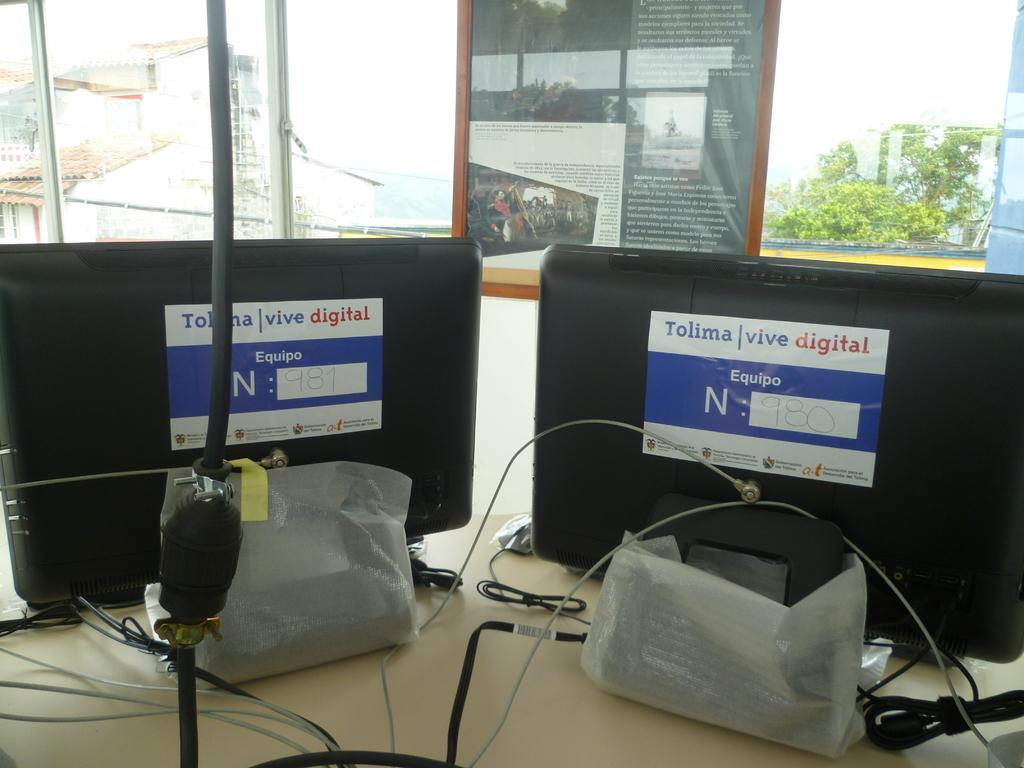How many systems can be seen in the image? There are two systems in the image. What is present in the image that connects the systems? There is a cable wire in the image that connects the systems. What type of furniture is in the image? There is a cupboard in the image. What can be seen through the window in the image? Houses and trees are visible through the window in the image. What type of bone can be seen in the image? There is no bone present in the image. How does the heat affect the systems in the image? The image does not provide information about heat or its effects on the systems. 